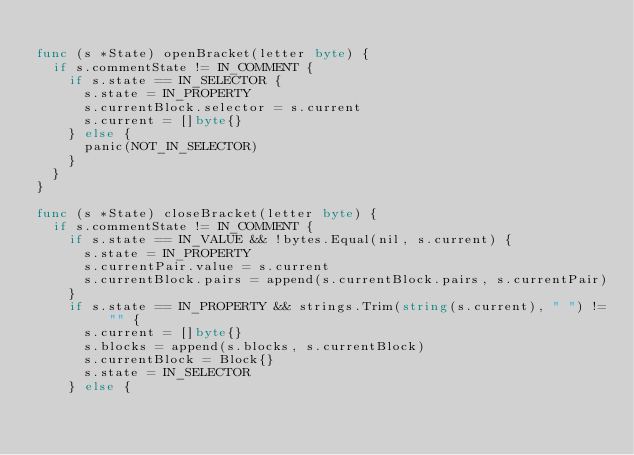<code> <loc_0><loc_0><loc_500><loc_500><_Go_>
func (s *State) openBracket(letter byte) {
	if s.commentState != IN_COMMENT {
		if s.state == IN_SELECTOR {
			s.state = IN_PROPERTY
			s.currentBlock.selector = s.current
			s.current = []byte{}
		} else {
			panic(NOT_IN_SELECTOR)
		}
	}
}

func (s *State) closeBracket(letter byte) {
	if s.commentState != IN_COMMENT {
		if s.state == IN_VALUE && !bytes.Equal(nil, s.current) {
			s.state = IN_PROPERTY
			s.currentPair.value = s.current
			s.currentBlock.pairs = append(s.currentBlock.pairs, s.currentPair)
		}
		if s.state == IN_PROPERTY && strings.Trim(string(s.current), " ") != "" {
			s.current = []byte{}
			s.blocks = append(s.blocks, s.currentBlock)
			s.currentBlock = Block{}
			s.state = IN_SELECTOR
		} else {</code> 